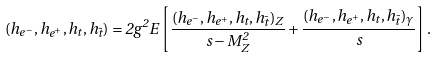<formula> <loc_0><loc_0><loc_500><loc_500>( h _ { e ^ { - } } , h _ { e ^ { + } } , h _ { t } , h _ { \bar { t } } ) = 2 g ^ { 2 } E \left [ \frac { ( h _ { e ^ { - } } , h _ { e ^ { + } } , h _ { t } , h _ { \bar { t } } ) _ { Z } } { s - M _ { Z } ^ { 2 } } + \frac { ( h _ { e ^ { - } } , h _ { e ^ { + } } , h _ { t } , h _ { \bar { t } } ) _ { \gamma } } { s } \right ] .</formula> 